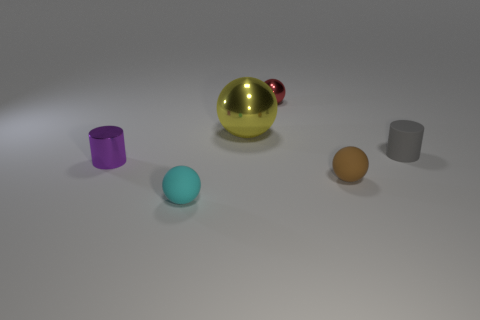There is a tiny metal thing that is to the right of the cylinder that is in front of the cylinder that is on the right side of the tiny metallic ball; what is its shape? The tiny metal object to the right of the cylinder in question appears to be spherical, which means it is ball-shaped. 